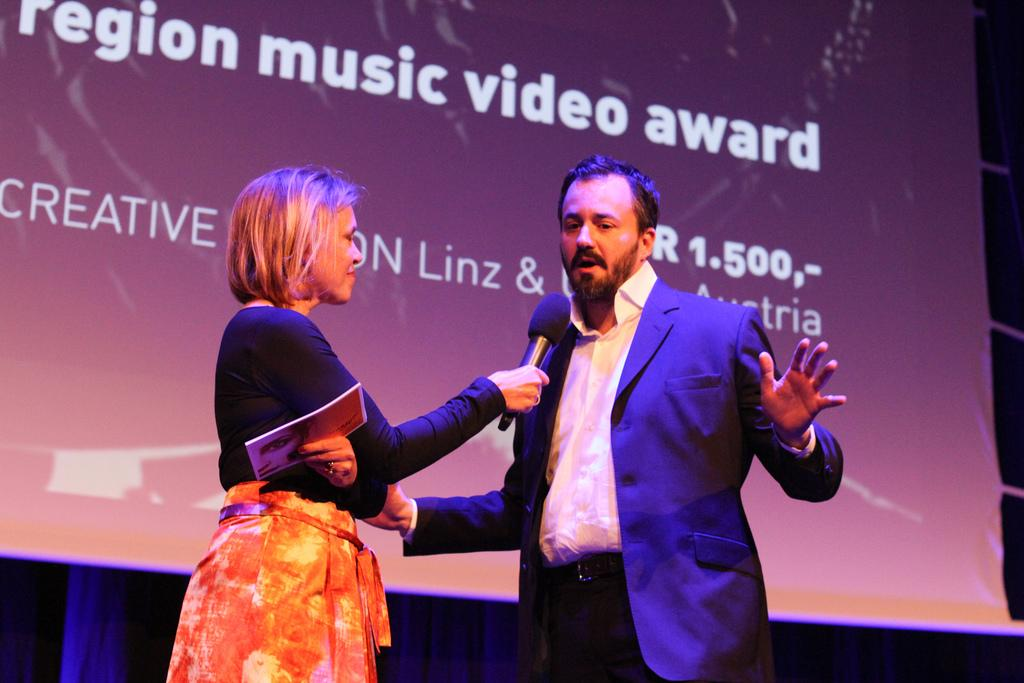How many people are present in the image? There are two people in the image. What is one of the people holding? One of the people is holding a mic and a paper. What can be seen in the background of the image? There is a screen and a curtain in the background of the image. What is visible on the screen? There is text visible on the screen. Can you tell me how many hens are visible on the screen in the image? There are no hens visible on the screen or in the image; the screen displays text. What type of mouth expression does the person holding the mic have? The image does not show the person's mouth expression, as it only displays the person holding a mic and a paper. 